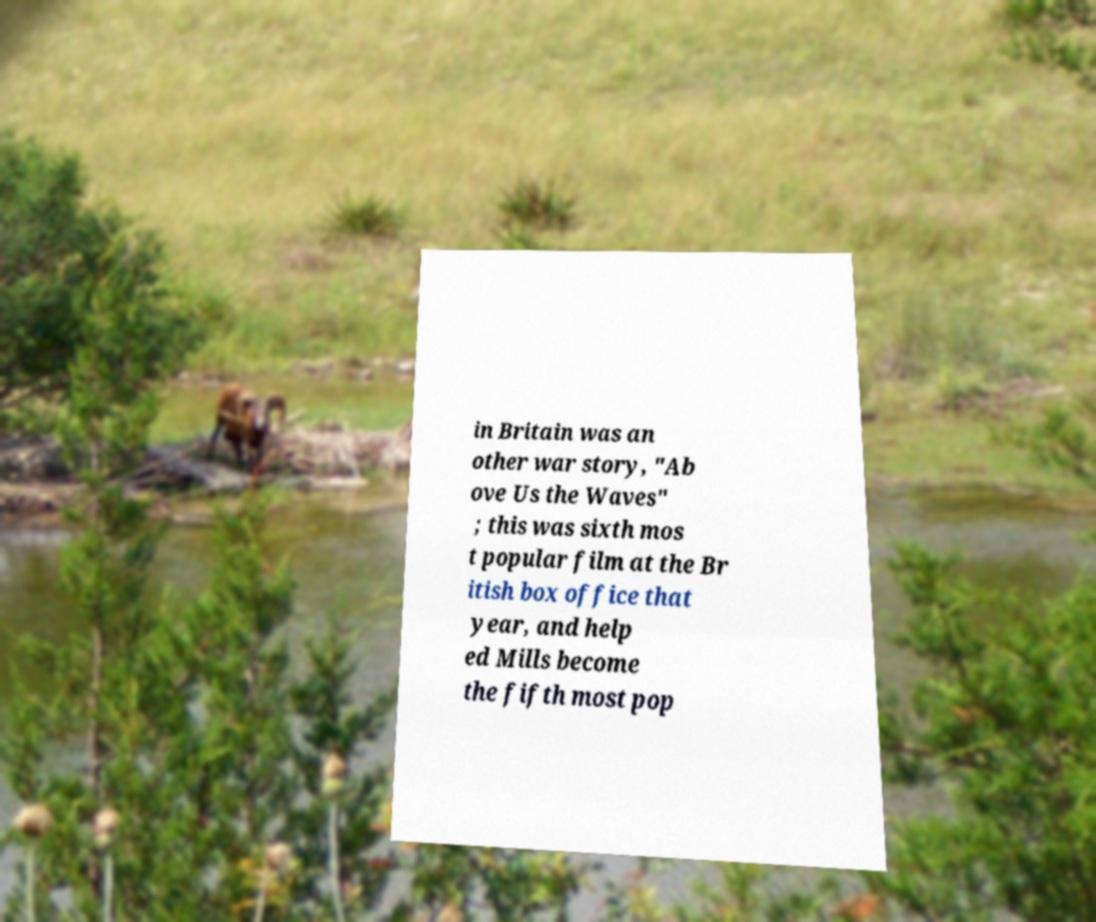What messages or text are displayed in this image? I need them in a readable, typed format. in Britain was an other war story, "Ab ove Us the Waves" ; this was sixth mos t popular film at the Br itish box office that year, and help ed Mills become the fifth most pop 